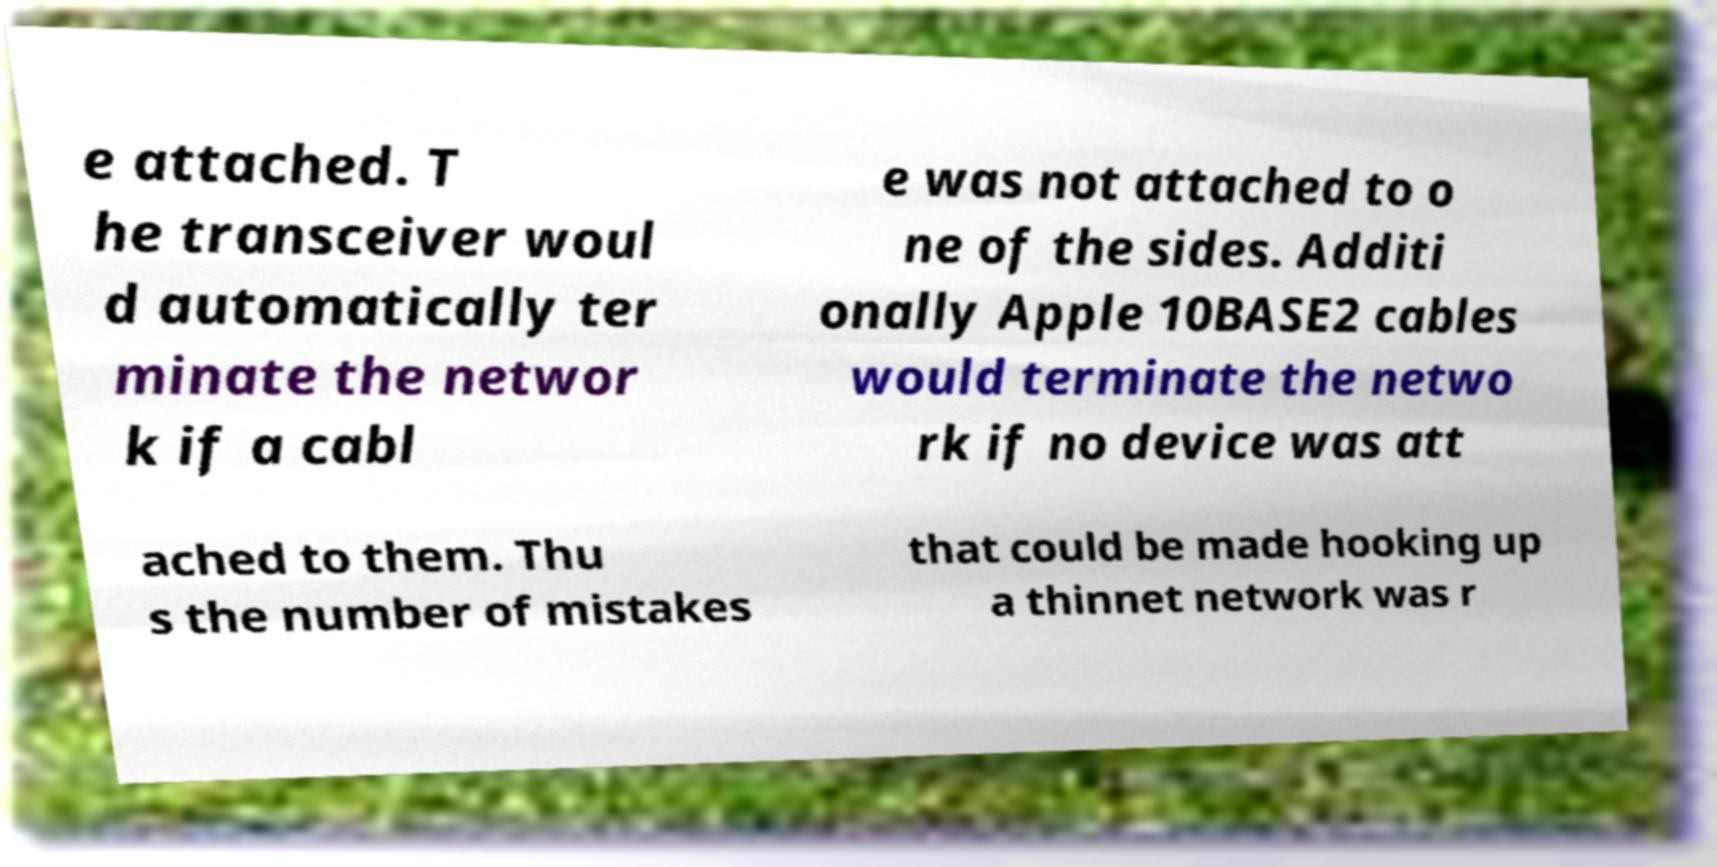What messages or text are displayed in this image? I need them in a readable, typed format. e attached. T he transceiver woul d automatically ter minate the networ k if a cabl e was not attached to o ne of the sides. Additi onally Apple 10BASE2 cables would terminate the netwo rk if no device was att ached to them. Thu s the number of mistakes that could be made hooking up a thinnet network was r 